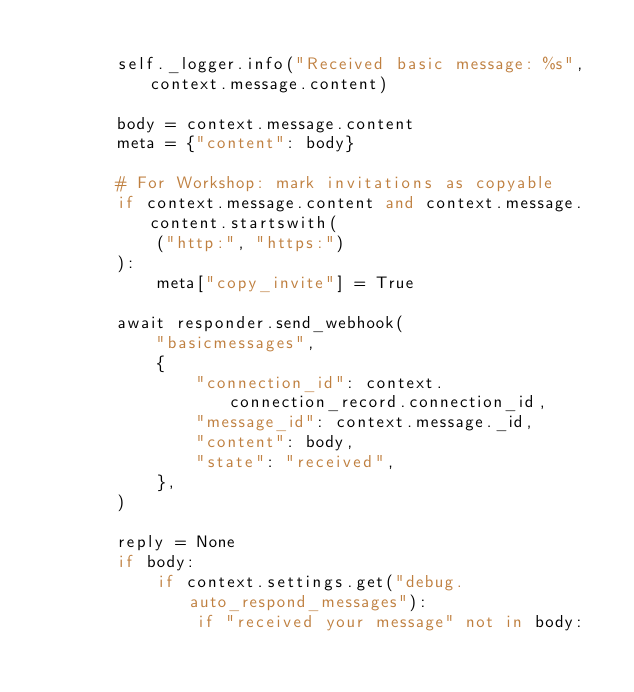Convert code to text. <code><loc_0><loc_0><loc_500><loc_500><_Python_>
        self._logger.info("Received basic message: %s", context.message.content)

        body = context.message.content
        meta = {"content": body}

        # For Workshop: mark invitations as copyable
        if context.message.content and context.message.content.startswith(
            ("http:", "https:")
        ):
            meta["copy_invite"] = True

        await responder.send_webhook(
            "basicmessages",
            {
                "connection_id": context.connection_record.connection_id,
                "message_id": context.message._id,
                "content": body,
                "state": "received",
            },
        )

        reply = None
        if body:
            if context.settings.get("debug.auto_respond_messages"):
                if "received your message" not in body:</code> 